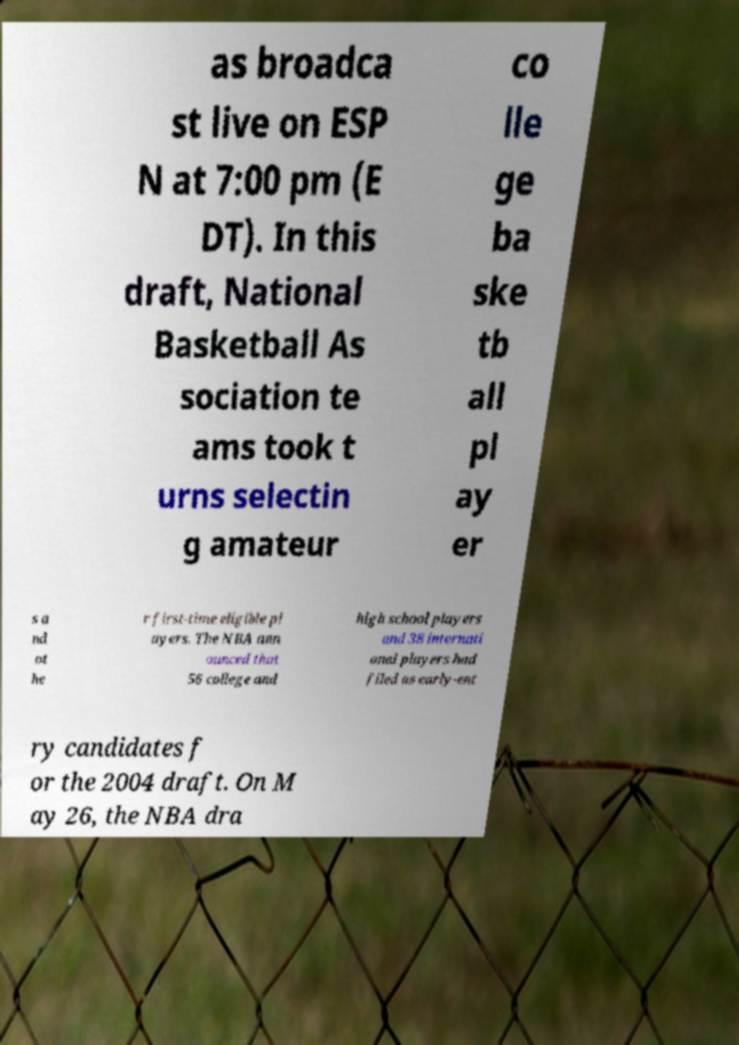I need the written content from this picture converted into text. Can you do that? as broadca st live on ESP N at 7:00 pm (E DT). In this draft, National Basketball As sociation te ams took t urns selectin g amateur co lle ge ba ske tb all pl ay er s a nd ot he r first-time eligible pl ayers. The NBA ann ounced that 56 college and high school players and 38 internati onal players had filed as early-ent ry candidates f or the 2004 draft. On M ay 26, the NBA dra 